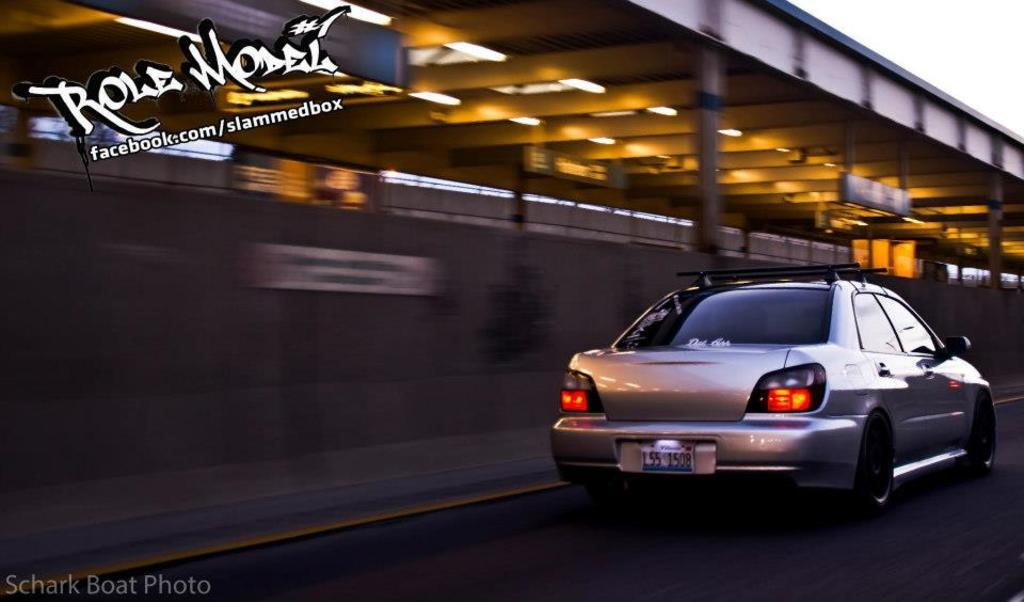What is the main subject of the image? The main subject of the image is a car on the road. What can be seen in the background of the image? There is a building and the sky visible in the background of the image. What type of net can be seen hanging from the car in the image? There is no net present in the image; it features a car on the road with a building and the sky visible in the background. 